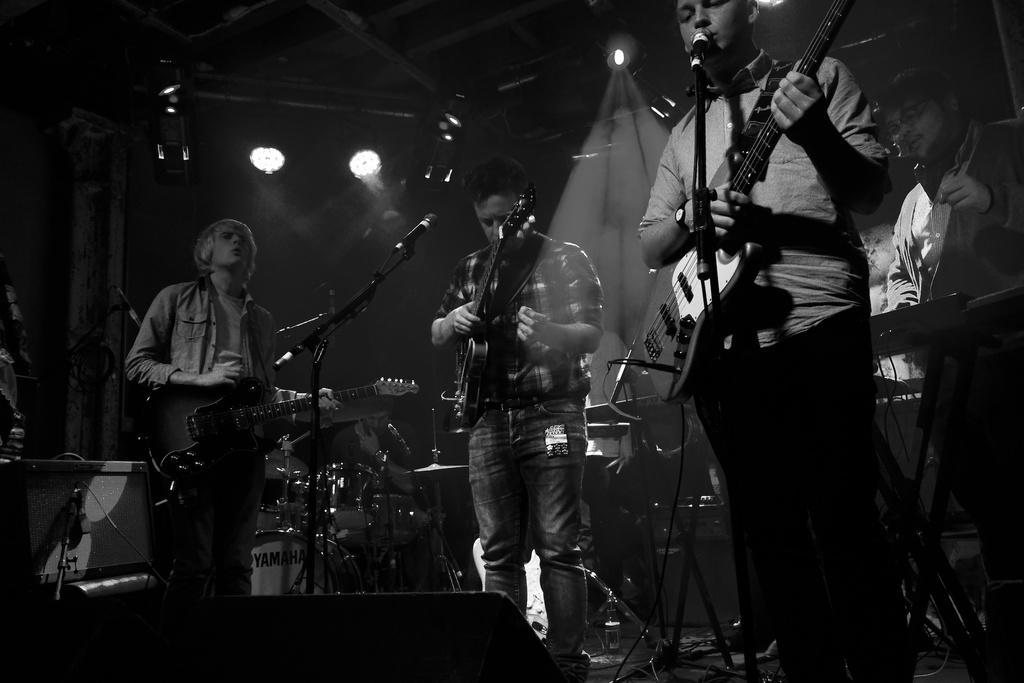Could you give a brief overview of what you see in this image? In this picture we can see four men standing and three are playing guitars holding in their hands and one is playing drums and other is playing piano and in front of them we have mic singing on it and in background we can see light, wall and it is dark. 